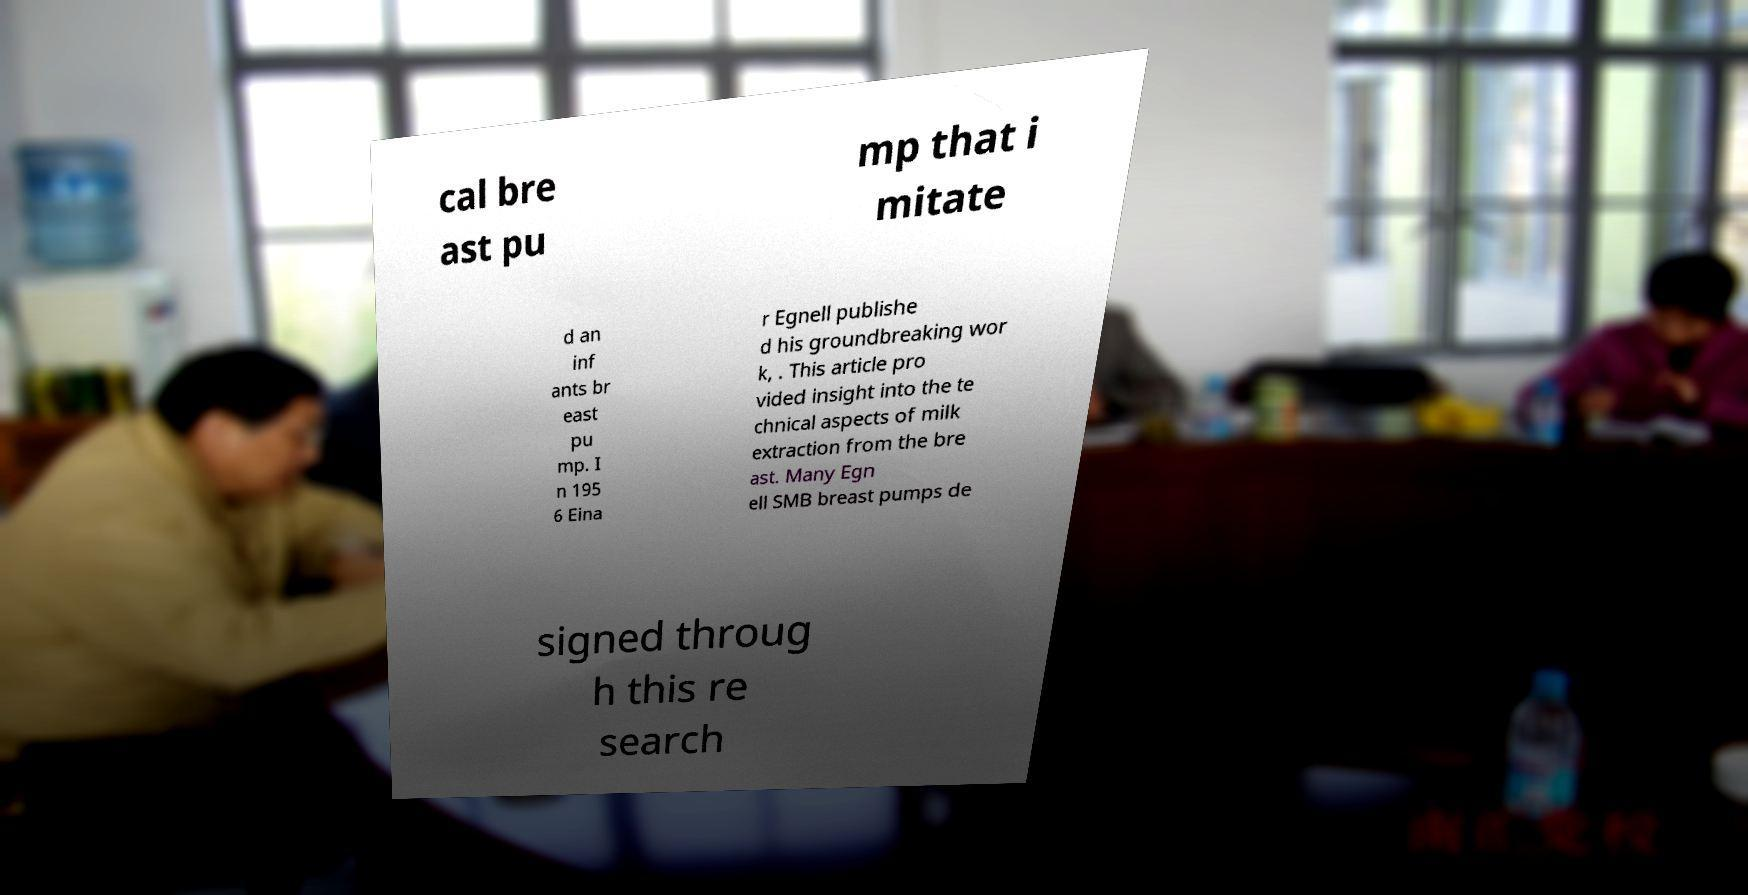For documentation purposes, I need the text within this image transcribed. Could you provide that? cal bre ast pu mp that i mitate d an inf ants br east pu mp. I n 195 6 Eina r Egnell publishe d his groundbreaking wor k, . This article pro vided insight into the te chnical aspects of milk extraction from the bre ast. Many Egn ell SMB breast pumps de signed throug h this re search 